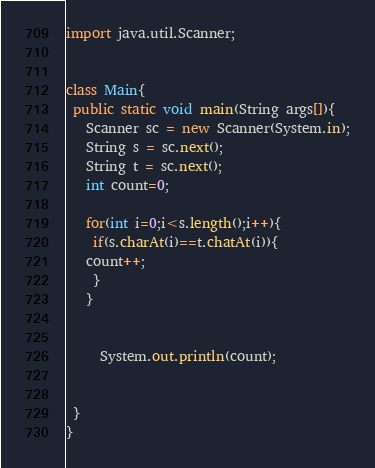Convert code to text. <code><loc_0><loc_0><loc_500><loc_500><_Java_>import java.util.Scanner;


class Main{
 public static void main(String args[]){
   Scanner sc = new Scanner(System.in);
   String s = sc.next();
   String t = sc.next();
   int count=0;
   
   for(int i=0;i<s.length();i++){
    if(s.charAt(i)==t.chatAt(i)){
   count++;
    }
   }

   
     System.out.println(count);
   
 
 }
}
</code> 